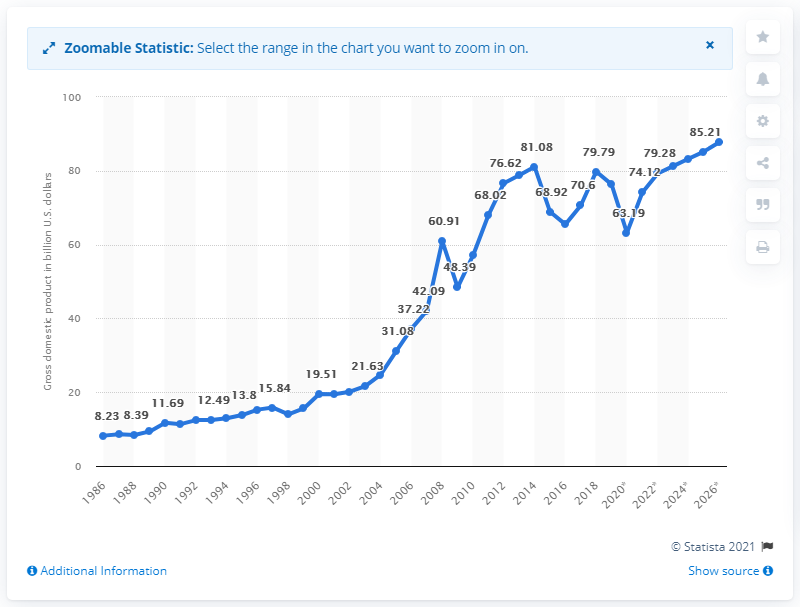Give some essential details in this illustration. In 2019, Oman's gross domestic product was 76.33. 